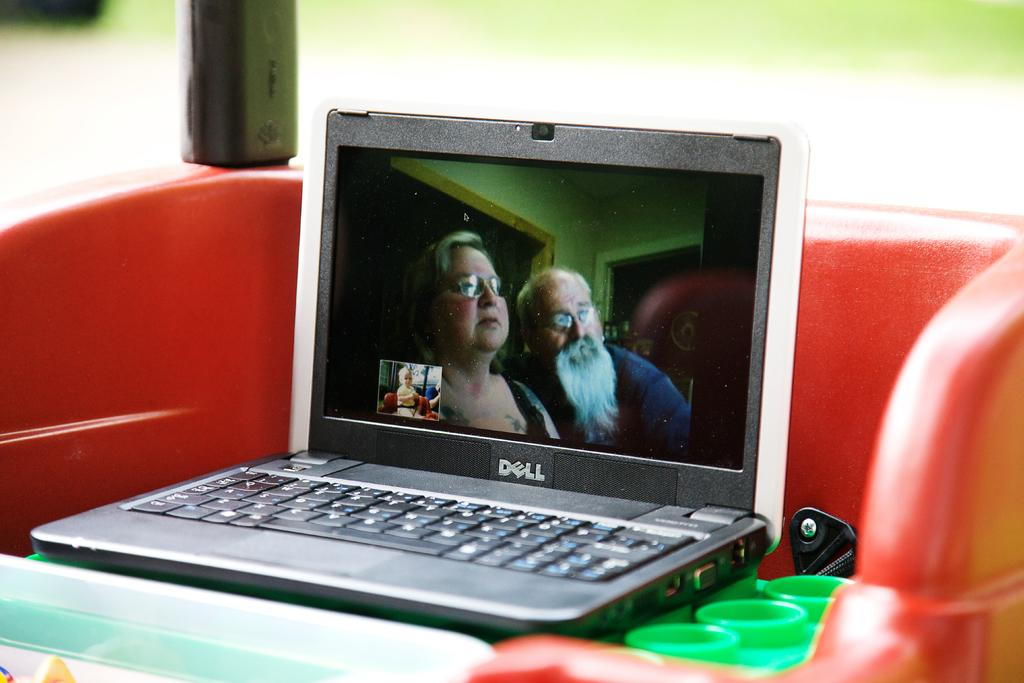<image>
Relay a brief, clear account of the picture shown. A Dell laptop is open and people are video chatting on it. 